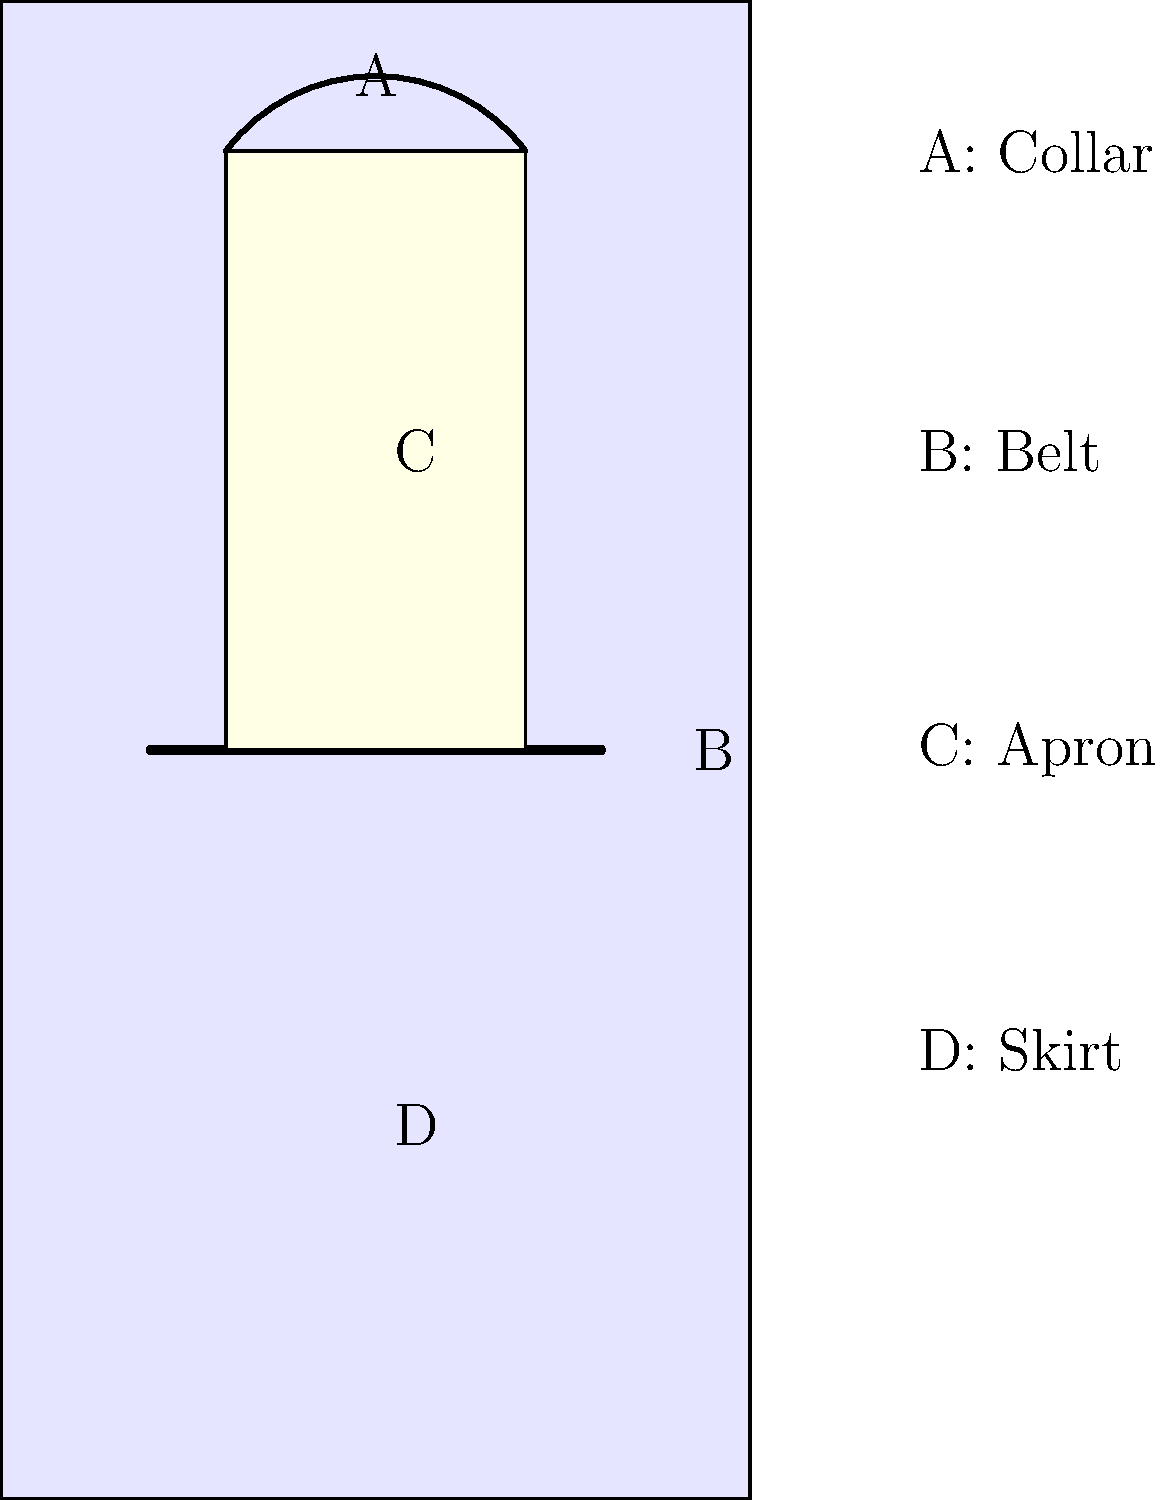In the traditional Finnish women's costume shown above, which element is typically decorated with intricate embroidery and often features regional patterns? To answer this question, let's consider each element of the traditional Finnish women's costume:

1. Collar (A): While sometimes decorated, it's not the main focus of embroidery.
2. Belt (B): Often made of woven fabric or leather, but not typically the primary canvas for intricate embroidery.
3. Apron (C): This is the key element. In traditional Finnish costumes, the apron is frequently adorned with elaborate embroidery. Different regions in Finland have their distinct patterns and motifs, making the apron a showcase of local craftsmanship and cultural identity.
4. Skirt (D): While an important part of the costume, it's usually made of solid-colored fabric and not the main focus of intricate embroidery.

The apron, being prominently displayed at the front of the costume, serves as an ideal canvas for showcasing intricate needlework and regional designs. It often tells a story about the wearer's origin and social status through its patterns and level of decoration.
Answer: Apron 